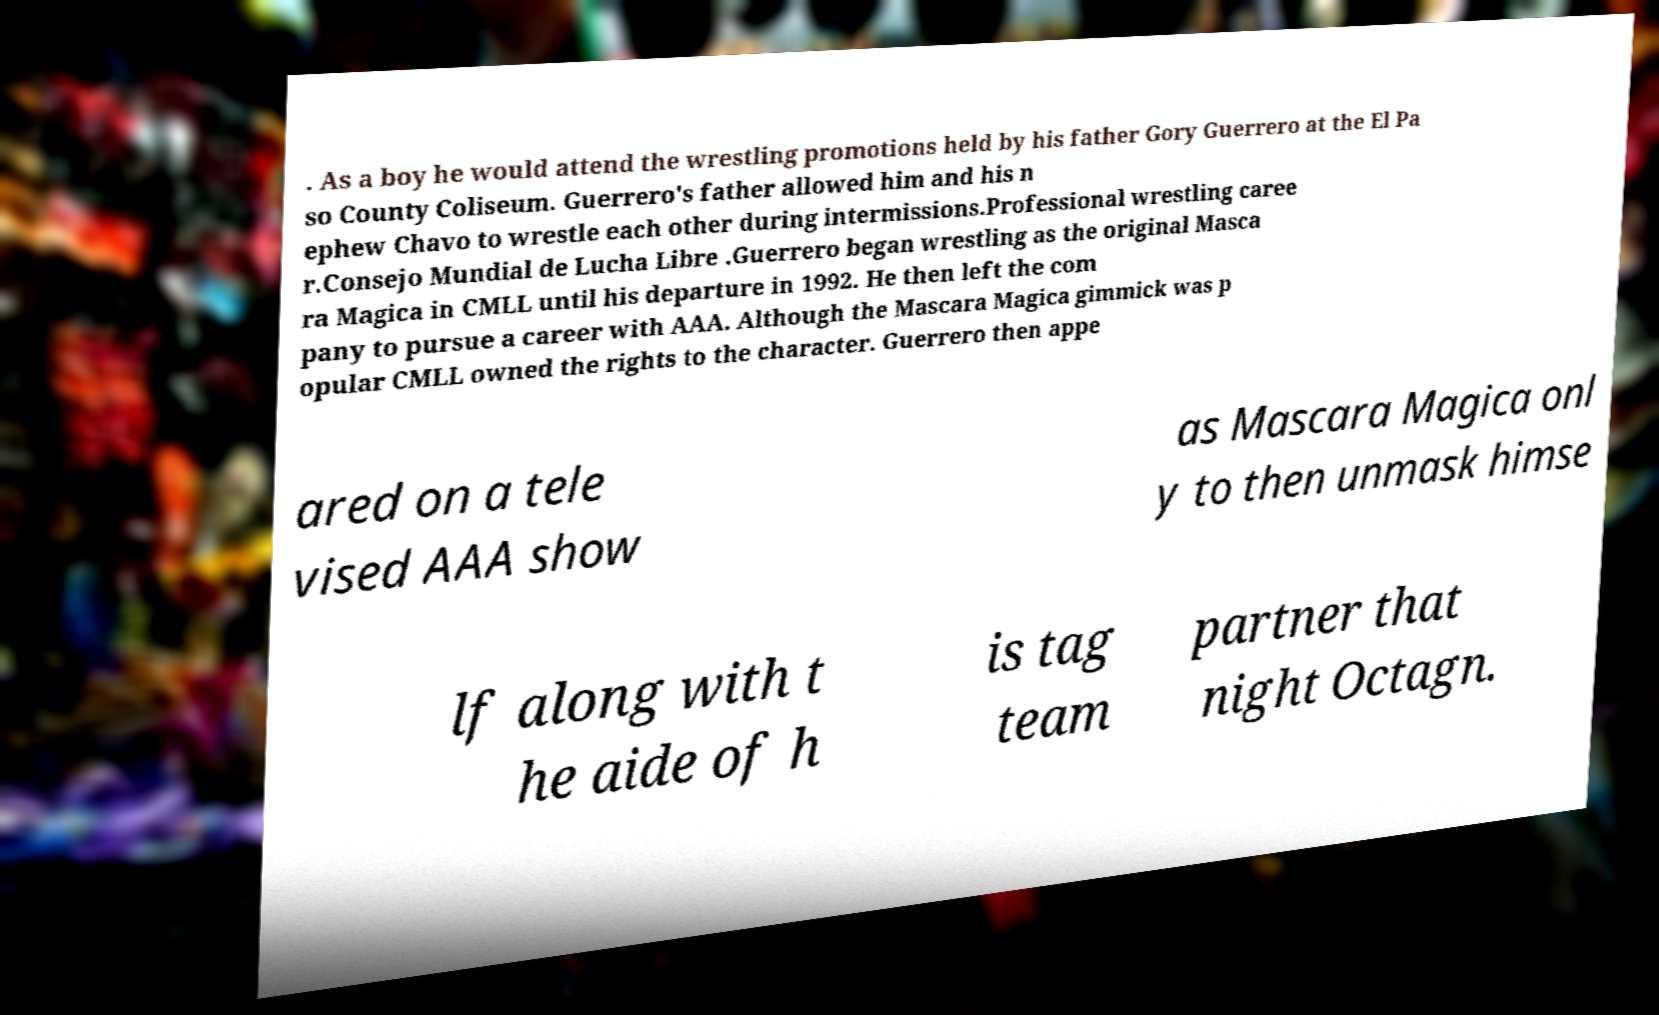I need the written content from this picture converted into text. Can you do that? . As a boy he would attend the wrestling promotions held by his father Gory Guerrero at the El Pa so County Coliseum. Guerrero's father allowed him and his n ephew Chavo to wrestle each other during intermissions.Professional wrestling caree r.Consejo Mundial de Lucha Libre .Guerrero began wrestling as the original Masca ra Magica in CMLL until his departure in 1992. He then left the com pany to pursue a career with AAA. Although the Mascara Magica gimmick was p opular CMLL owned the rights to the character. Guerrero then appe ared on a tele vised AAA show as Mascara Magica onl y to then unmask himse lf along with t he aide of h is tag team partner that night Octagn. 